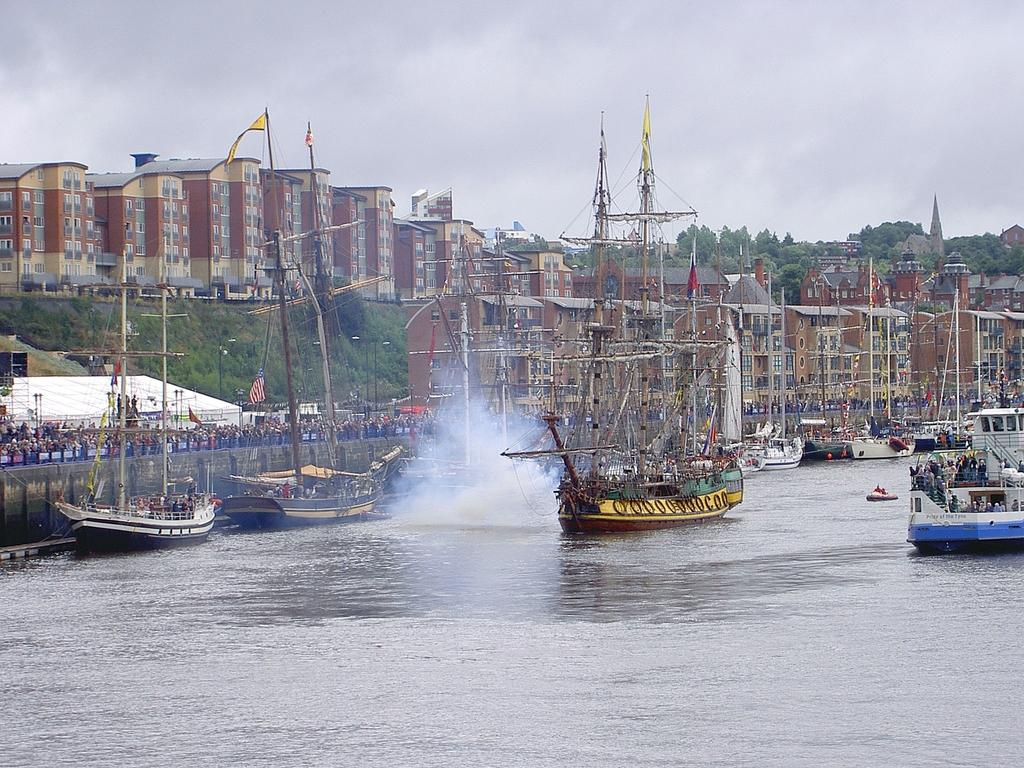What type of structures can be seen in the image? There are buildings in the image. What natural elements are present in the image? There are trees in the image. What man-made objects can be seen in the image? There are flags and poles in the image. What is happening on the water in the image? There are boats on the surface of the water in the image. What type of barrier is visible in the image? There is a wall in the image. Who or what is present in the image? There are people in the image. What is the condition of the sky in the image? The sky is visible in the image and appears to be cloudy. What type of plantation is visible in the image? There is no plantation present in the image. How many clouds are visible in the image? The question cannot be answered definitively as the number of clouds is not specified in the facts provided. 